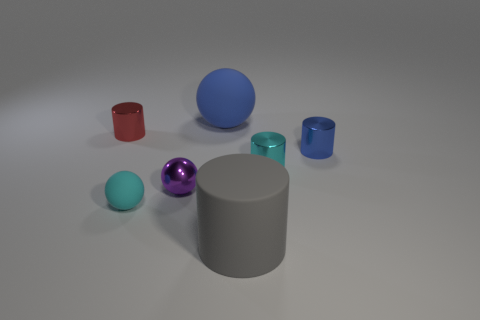There is another small rubber object that is the same shape as the small purple object; what is its color?
Make the answer very short. Cyan. Is the number of small metal objects that are on the right side of the small rubber object less than the number of large gray cylinders right of the cyan cylinder?
Keep it short and to the point. No. Are there any other things that have the same size as the purple sphere?
Keep it short and to the point. Yes. How big is the cyan cylinder?
Your answer should be compact. Small. How many big objects are either matte things or red things?
Your response must be concise. 2. Is the size of the blue rubber object the same as the cyan sphere on the left side of the gray cylinder?
Keep it short and to the point. No. Is there anything else that is the same shape as the small red object?
Your response must be concise. Yes. What number of tiny metallic cylinders are there?
Your answer should be very brief. 3. What number of gray things are either big rubber spheres or rubber cylinders?
Give a very brief answer. 1. Does the small cyan object that is on the left side of the rubber cylinder have the same material as the big gray thing?
Make the answer very short. Yes. 